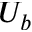<formula> <loc_0><loc_0><loc_500><loc_500>U _ { b }</formula> 